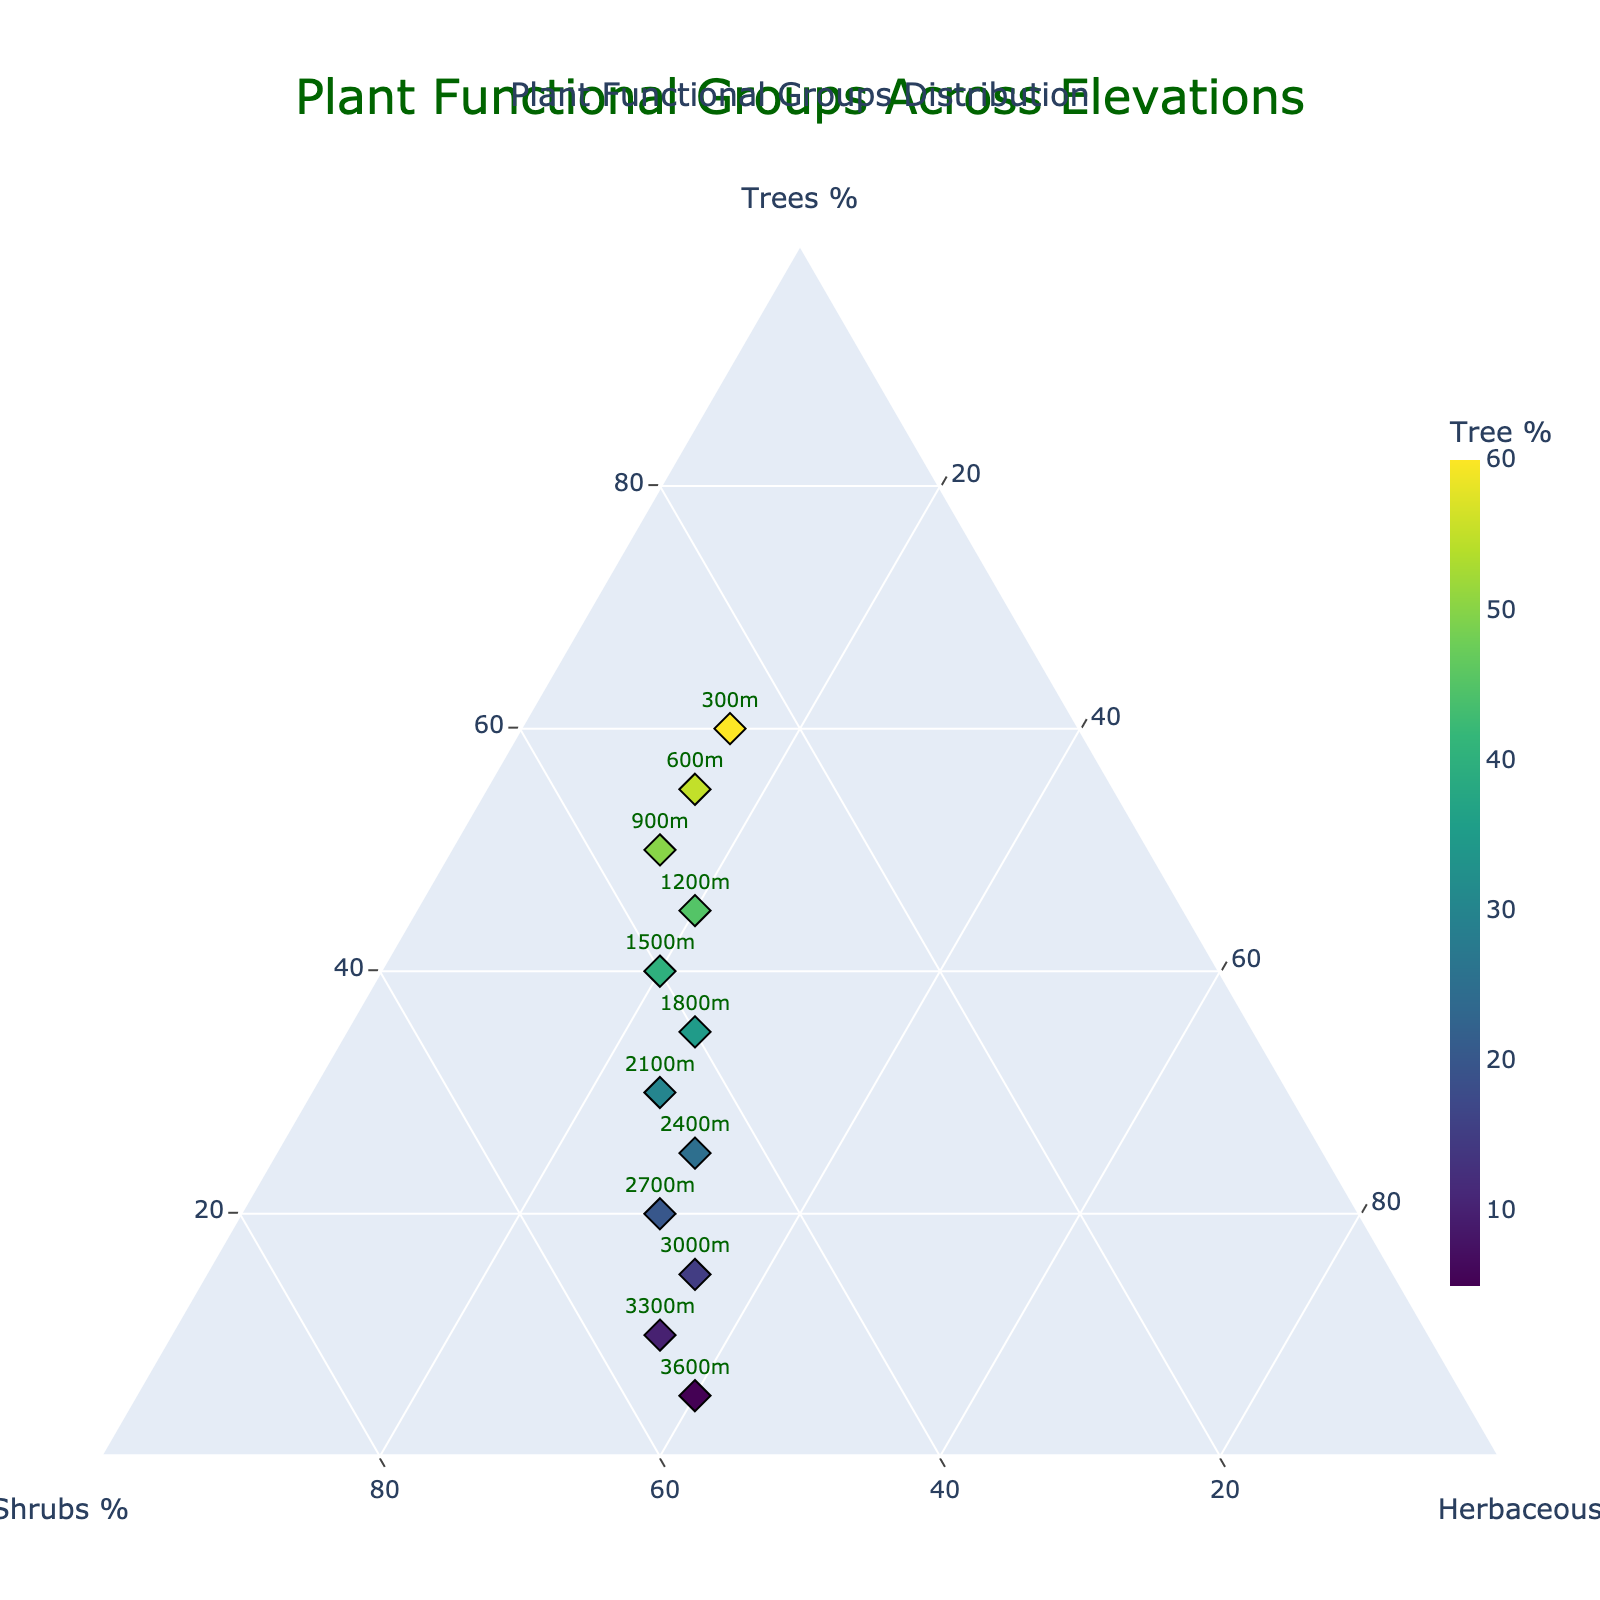What is the title of the figure? The title of the figure is visually displayed at the top center of the plot.
Answer: Plant Functional Groups Across Elevations How many elevations are represented in the plot? The elevations are listed next to the markers, and each marker represents one elevation point.
Answer: 12 Which plant functional group has the highest relative abundance at 300m elevation? At 300m elevation, the position of the marker indicates the proportions of Trees, Shrubs, and Herbaceous plants. The highest value among them will identify the most abundant group.
Answer: Trees As we move from 900m to 1800m elevation, how does the relative abundance of shrubs change? By observing the position of the markers from 900m to 1800m, we can see that the Shrubs percentage increases from 35% to 40%.
Answer: Increases What is the relative abundance of herbaceous plants at 2400m elevation? The marker at 2400m elevation will show the respective percentages of all plant groups. The percentage for Herbaceous plants can be read directly.
Answer: 30% Are trees more abundant at 1200m or 2700m elevation? The positions of the markers for 1200m and 2700m elevations will show the respective Tree percentages. Comparing these values will indicate the greater percentage.
Answer: 1200m What is the range of relative abundance for Shrubs observed in the plot? Observing the highest and lowest values of Shrubs percentages across all elevations will give the range. The markers vary from 25% to 55%.
Answer: 25% to 55% At which elevation do Herbaceous plants reach their highest relative abundance? Reviewing all the markers, identify the one with the highest percentage of Herbaceous plants, which occurs at 3600m.
Answer: 3600m Compare the relative abundance of Trees and Shrubs at 3000m elevation. Which group is more abundant? The marker at 3000m will provide the percentage values. Trees are at 15% and Shrubs are at 50%, making Shrubs more abundant.
Answer: Shrubs What pattern emerges for Tree abundance as elevation increases from 300m to 3600m? Moving from 300m to 3600m, observe the trend in the relative abundance of Trees. The percentage consistently decreases.
Answer: Decreases 